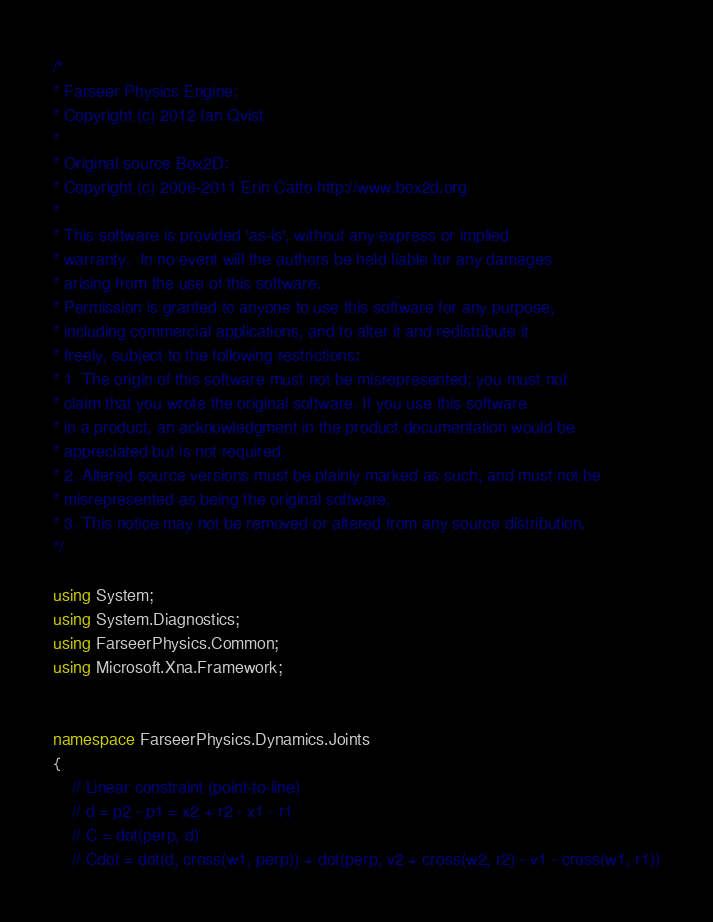Convert code to text. <code><loc_0><loc_0><loc_500><loc_500><_C#_>/*
* Farseer Physics Engine:
* Copyright (c) 2012 Ian Qvist
* 
* Original source Box2D:
* Copyright (c) 2006-2011 Erin Catto http://www.box2d.org 
* 
* This software is provided 'as-is', without any express or implied 
* warranty.  In no event will the authors be held liable for any damages 
* arising from the use of this software. 
* Permission is granted to anyone to use this software for any purpose, 
* including commercial applications, and to alter it and redistribute it 
* freely, subject to the following restrictions: 
* 1. The origin of this software must not be misrepresented; you must not 
* claim that you wrote the original software. If you use this software 
* in a product, an acknowledgment in the product documentation would be 
* appreciated but is not required. 
* 2. Altered source versions must be plainly marked as such, and must not be 
* misrepresented as being the original software. 
* 3. This notice may not be removed or altered from any source distribution. 
*/

using System;
using System.Diagnostics;
using FarseerPhysics.Common;
using Microsoft.Xna.Framework;


namespace FarseerPhysics.Dynamics.Joints
{
	// Linear constraint (point-to-line)
	// d = p2 - p1 = x2 + r2 - x1 - r1
	// C = dot(perp, d)
	// Cdot = dot(d, cross(w1, perp)) + dot(perp, v2 + cross(w2, r2) - v1 - cross(w1, r1))</code> 